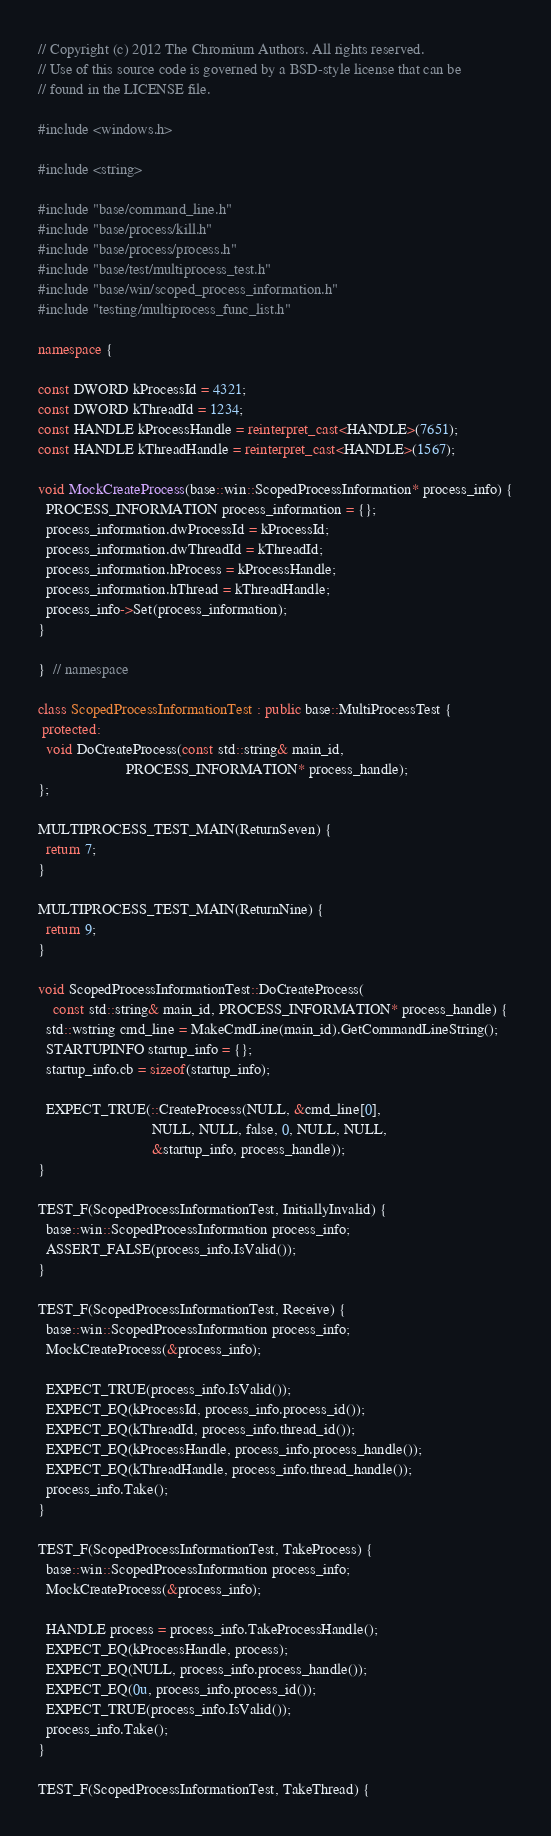Convert code to text. <code><loc_0><loc_0><loc_500><loc_500><_C++_>// Copyright (c) 2012 The Chromium Authors. All rights reserved.
// Use of this source code is governed by a BSD-style license that can be
// found in the LICENSE file.

#include <windows.h>

#include <string>

#include "base/command_line.h"
#include "base/process/kill.h"
#include "base/process/process.h"
#include "base/test/multiprocess_test.h"
#include "base/win/scoped_process_information.h"
#include "testing/multiprocess_func_list.h"

namespace {

const DWORD kProcessId = 4321;
const DWORD kThreadId = 1234;
const HANDLE kProcessHandle = reinterpret_cast<HANDLE>(7651);
const HANDLE kThreadHandle = reinterpret_cast<HANDLE>(1567);

void MockCreateProcess(base::win::ScopedProcessInformation* process_info) {
  PROCESS_INFORMATION process_information = {};
  process_information.dwProcessId = kProcessId;
  process_information.dwThreadId = kThreadId;
  process_information.hProcess = kProcessHandle;
  process_information.hThread = kThreadHandle;
  process_info->Set(process_information);
}

}  // namespace

class ScopedProcessInformationTest : public base::MultiProcessTest {
 protected:
  void DoCreateProcess(const std::string& main_id,
                       PROCESS_INFORMATION* process_handle);
};

MULTIPROCESS_TEST_MAIN(ReturnSeven) {
  return 7;
}

MULTIPROCESS_TEST_MAIN(ReturnNine) {
  return 9;
}

void ScopedProcessInformationTest::DoCreateProcess(
    const std::string& main_id, PROCESS_INFORMATION* process_handle) {
  std::wstring cmd_line = MakeCmdLine(main_id).GetCommandLineString();
  STARTUPINFO startup_info = {};
  startup_info.cb = sizeof(startup_info);

  EXPECT_TRUE(::CreateProcess(NULL, &cmd_line[0],
                              NULL, NULL, false, 0, NULL, NULL,
                              &startup_info, process_handle));
}

TEST_F(ScopedProcessInformationTest, InitiallyInvalid) {
  base::win::ScopedProcessInformation process_info;
  ASSERT_FALSE(process_info.IsValid());
}

TEST_F(ScopedProcessInformationTest, Receive) {
  base::win::ScopedProcessInformation process_info;
  MockCreateProcess(&process_info);

  EXPECT_TRUE(process_info.IsValid());
  EXPECT_EQ(kProcessId, process_info.process_id());
  EXPECT_EQ(kThreadId, process_info.thread_id());
  EXPECT_EQ(kProcessHandle, process_info.process_handle());
  EXPECT_EQ(kThreadHandle, process_info.thread_handle());
  process_info.Take();
}

TEST_F(ScopedProcessInformationTest, TakeProcess) {
  base::win::ScopedProcessInformation process_info;
  MockCreateProcess(&process_info);

  HANDLE process = process_info.TakeProcessHandle();
  EXPECT_EQ(kProcessHandle, process);
  EXPECT_EQ(NULL, process_info.process_handle());
  EXPECT_EQ(0u, process_info.process_id());
  EXPECT_TRUE(process_info.IsValid());
  process_info.Take();
}

TEST_F(ScopedProcessInformationTest, TakeThread) {</code> 